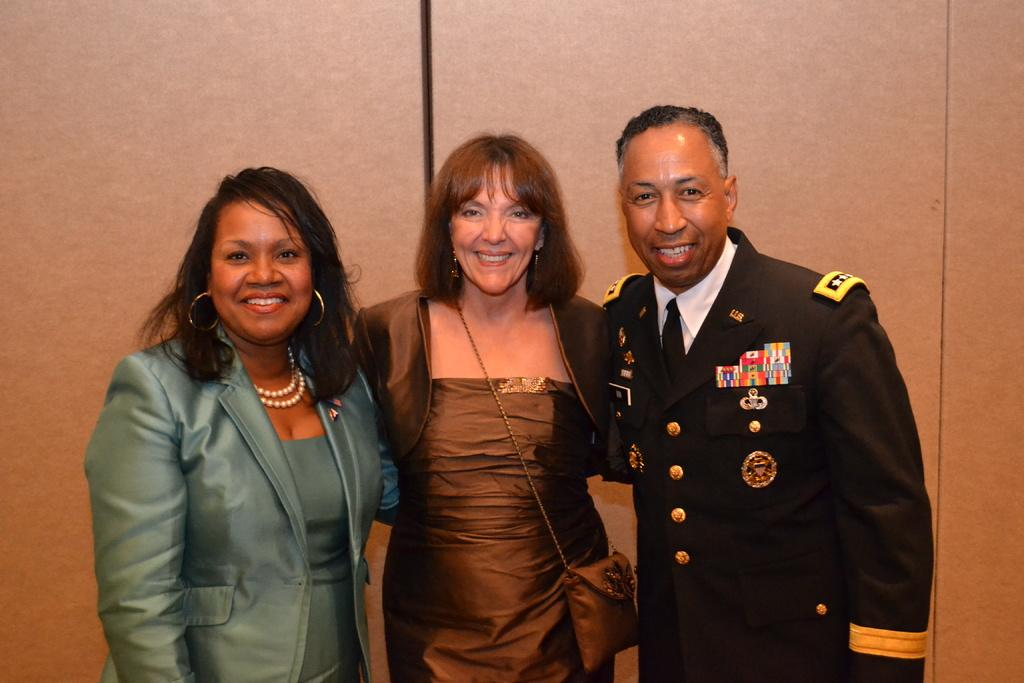How many people are in the image? There are three people in the image. What are the people in the image doing? The people are standing in the image. What expressions do the people have? The people are smiling in the image. What is visible in the background of the image? There is a wall in the background of the image. What type of nose can be seen on the wall in the image? There is no nose present on the wall in the image. How does the spot on the wall increase in size over time in the image? There is no spot on the wall in the image, and therefore no such increase in size can be observed. 